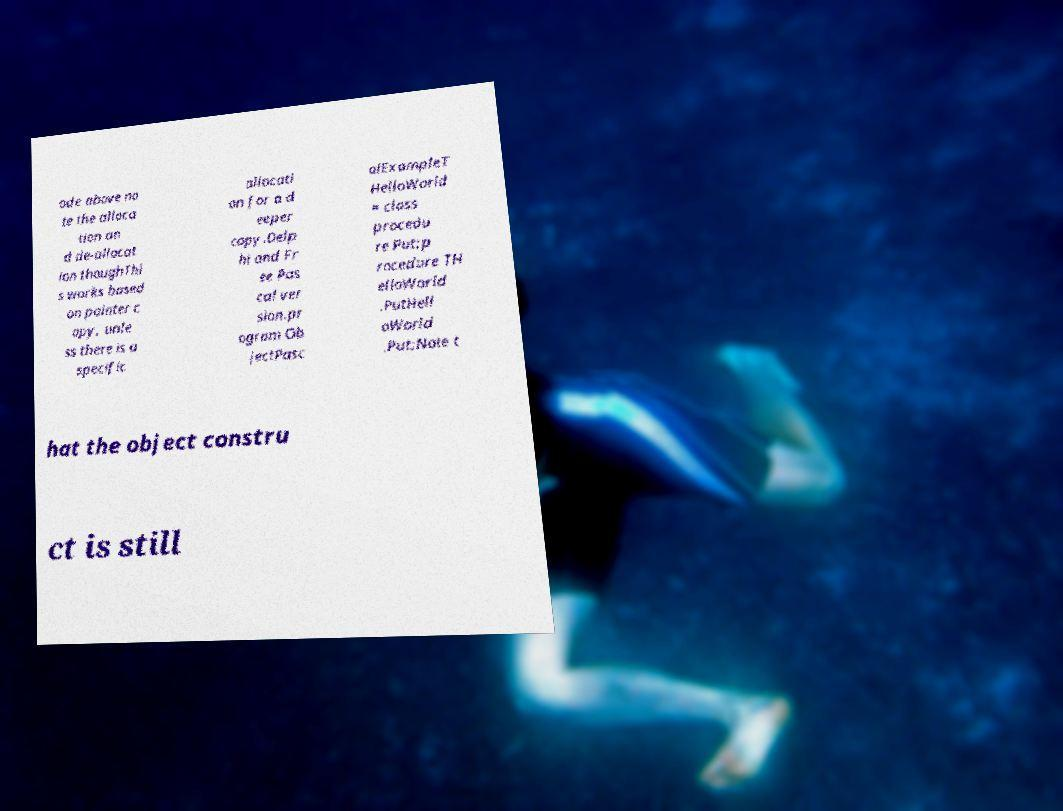Please identify and transcribe the text found in this image. ode above no te the alloca tion an d de-allocat ion thoughThi s works based on pointer c opy, unle ss there is a specific allocati on for a d eeper copy.Delp hi and Fr ee Pas cal ver sion.pr ogram Ob jectPasc alExampleT HelloWorld = class procedu re Put;p rocedure TH elloWorld .PutHell oWorld .Put;Note t hat the object constru ct is still 